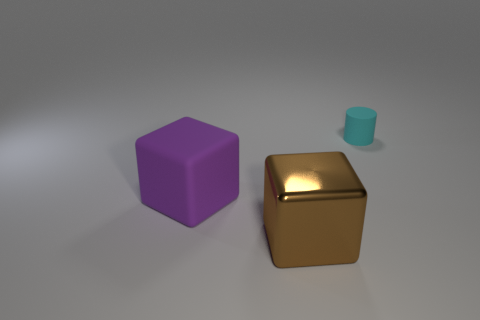Is there any other thing that is the same material as the large brown object?
Your response must be concise. No. The brown metal object has what size?
Offer a very short reply. Large. How many other objects are the same color as the small cylinder?
Give a very brief answer. 0. Is the thing on the left side of the brown object made of the same material as the tiny cyan thing?
Your response must be concise. Yes. Is the number of purple rubber blocks on the left side of the purple block less than the number of small things right of the cyan rubber thing?
Offer a very short reply. No. What number of other things are there of the same material as the large purple thing
Make the answer very short. 1. What material is the other block that is the same size as the brown cube?
Offer a terse response. Rubber. Are there fewer large purple rubber things in front of the big shiny block than green shiny spheres?
Provide a short and direct response. No. There is a big thing behind the big object on the right side of the matte thing that is in front of the tiny matte thing; what shape is it?
Your answer should be compact. Cube. How big is the matte thing to the right of the large shiny thing?
Ensure brevity in your answer.  Small. 